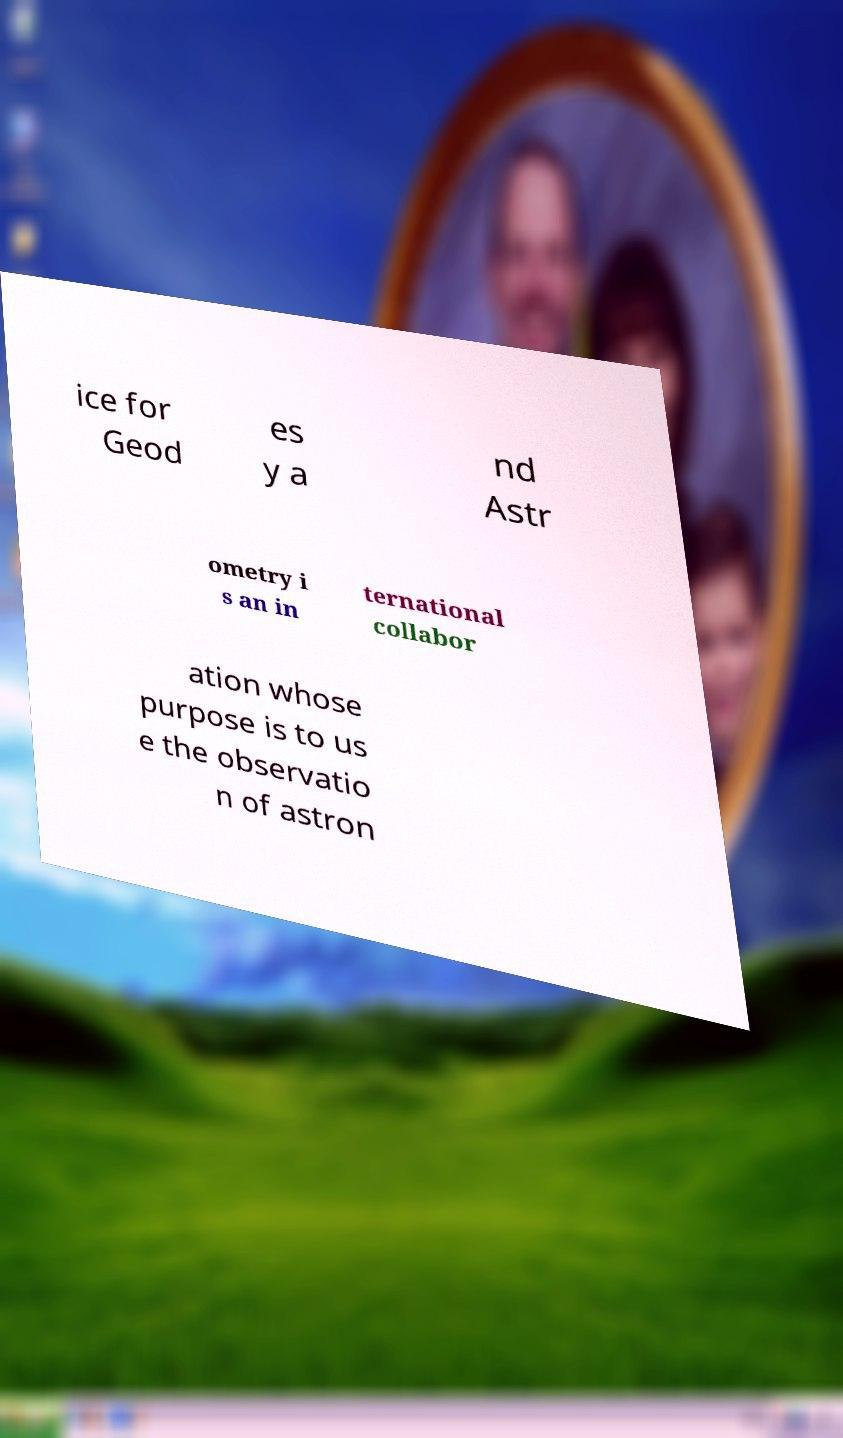Please identify and transcribe the text found in this image. ice for Geod es y a nd Astr ometry i s an in ternational collabor ation whose purpose is to us e the observatio n of astron 